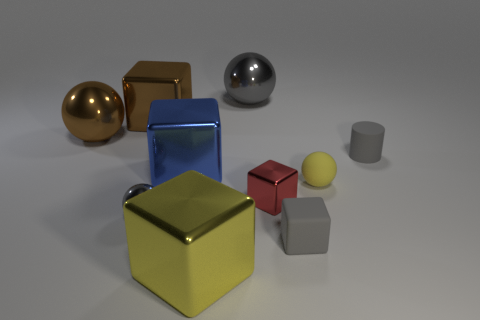Subtract all cyan cubes. Subtract all brown cylinders. How many cubes are left? 5 Subtract all cylinders. How many objects are left? 9 Add 8 small cylinders. How many small cylinders exist? 9 Subtract 0 purple balls. How many objects are left? 10 Subtract all tiny gray balls. Subtract all tiny yellow objects. How many objects are left? 8 Add 6 large gray balls. How many large gray balls are left? 7 